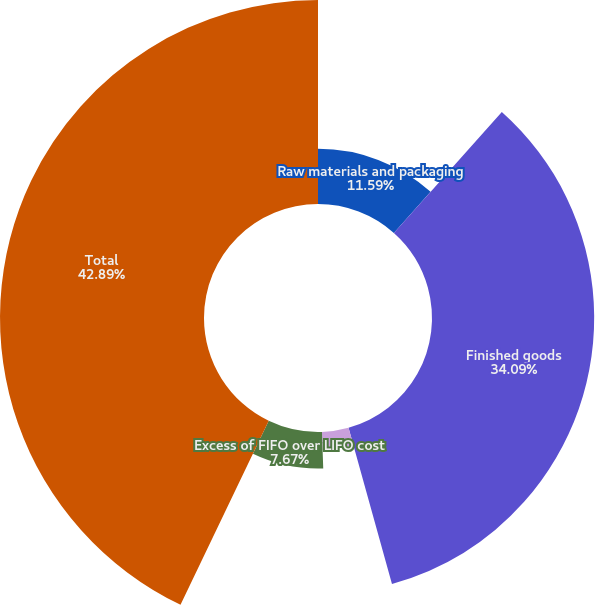Convert chart to OTSL. <chart><loc_0><loc_0><loc_500><loc_500><pie_chart><fcel>Raw materials and packaging<fcel>Finished goods<fcel>Grain<fcel>Excess of FIFO over LIFO cost<fcel>Total<nl><fcel>11.59%<fcel>34.09%<fcel>3.76%<fcel>7.67%<fcel>42.88%<nl></chart> 